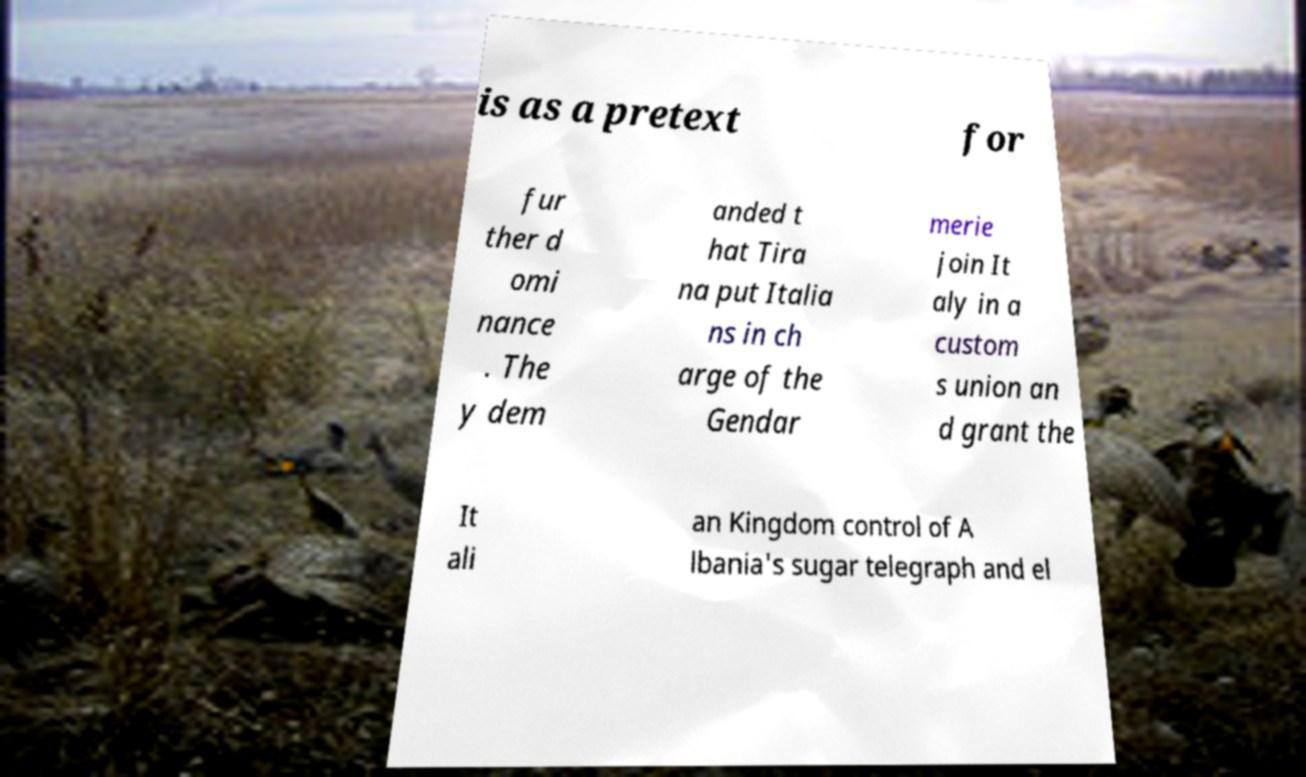There's text embedded in this image that I need extracted. Can you transcribe it verbatim? is as a pretext for fur ther d omi nance . The y dem anded t hat Tira na put Italia ns in ch arge of the Gendar merie join It aly in a custom s union an d grant the It ali an Kingdom control of A lbania's sugar telegraph and el 